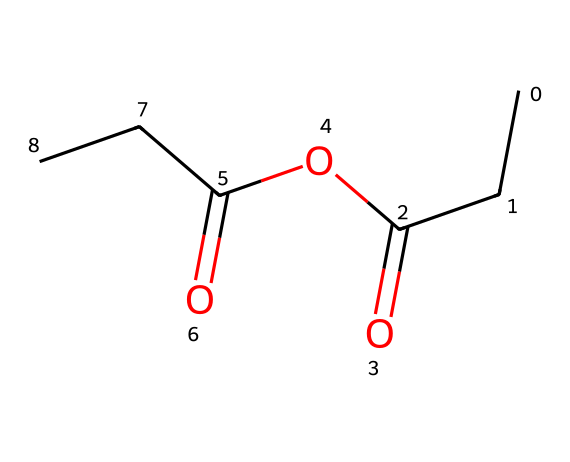What is the molecular formula of propionic anhydride? The molecular formula can be derived by counting the number of each type of atom in the structure represented by the SMILES. The structure shows 5 carbon atoms (C), 8 hydrogen atoms (H), and 2 oxygen atoms (O), thus giving the formula C5H8O2.
Answer: C5H8O2 How many carbon atoms are in propionic anhydride? By analyzing the SMILES, there are five "C" characters in the structure, indicating there are five carbon atoms present.
Answer: 5 Is propionic anhydride a symmetrical molecule? The molecular structure shows that there are two acyl groups on either side connected through the anhydride linkage, making it symmetrical. Thus, both acyl groups are identical, confirming symmetry.
Answer: Yes What type of functional group is present in propionic anhydride? By recognizing that the structure contains the anhydride functional group (characterized by the presence of two acyl groups linked by an oxygen atom), we can classify it as an anhydride.
Answer: Anhydride What is the degree of unsaturation in propionic anhydride? The degree of unsaturation can be determined by the formula (2C + 2 + N - H - X) / 2. For C5H8O2, substituting gives (2(5) + 2 - 8) / 2 = 2. This indicates two double bonds or rings are present in the structure.
Answer: 2 What type of reactions can propionic anhydride undergo? As an acid anhydride, propionic anhydride can undergo hydrolysis and acylation reactions. It can react with water to form propionic acid or with alcohols in transesterification processes, indicating its reactive nature due to the presence of the anhydride bond.
Answer: Hydrolysis, acylation 